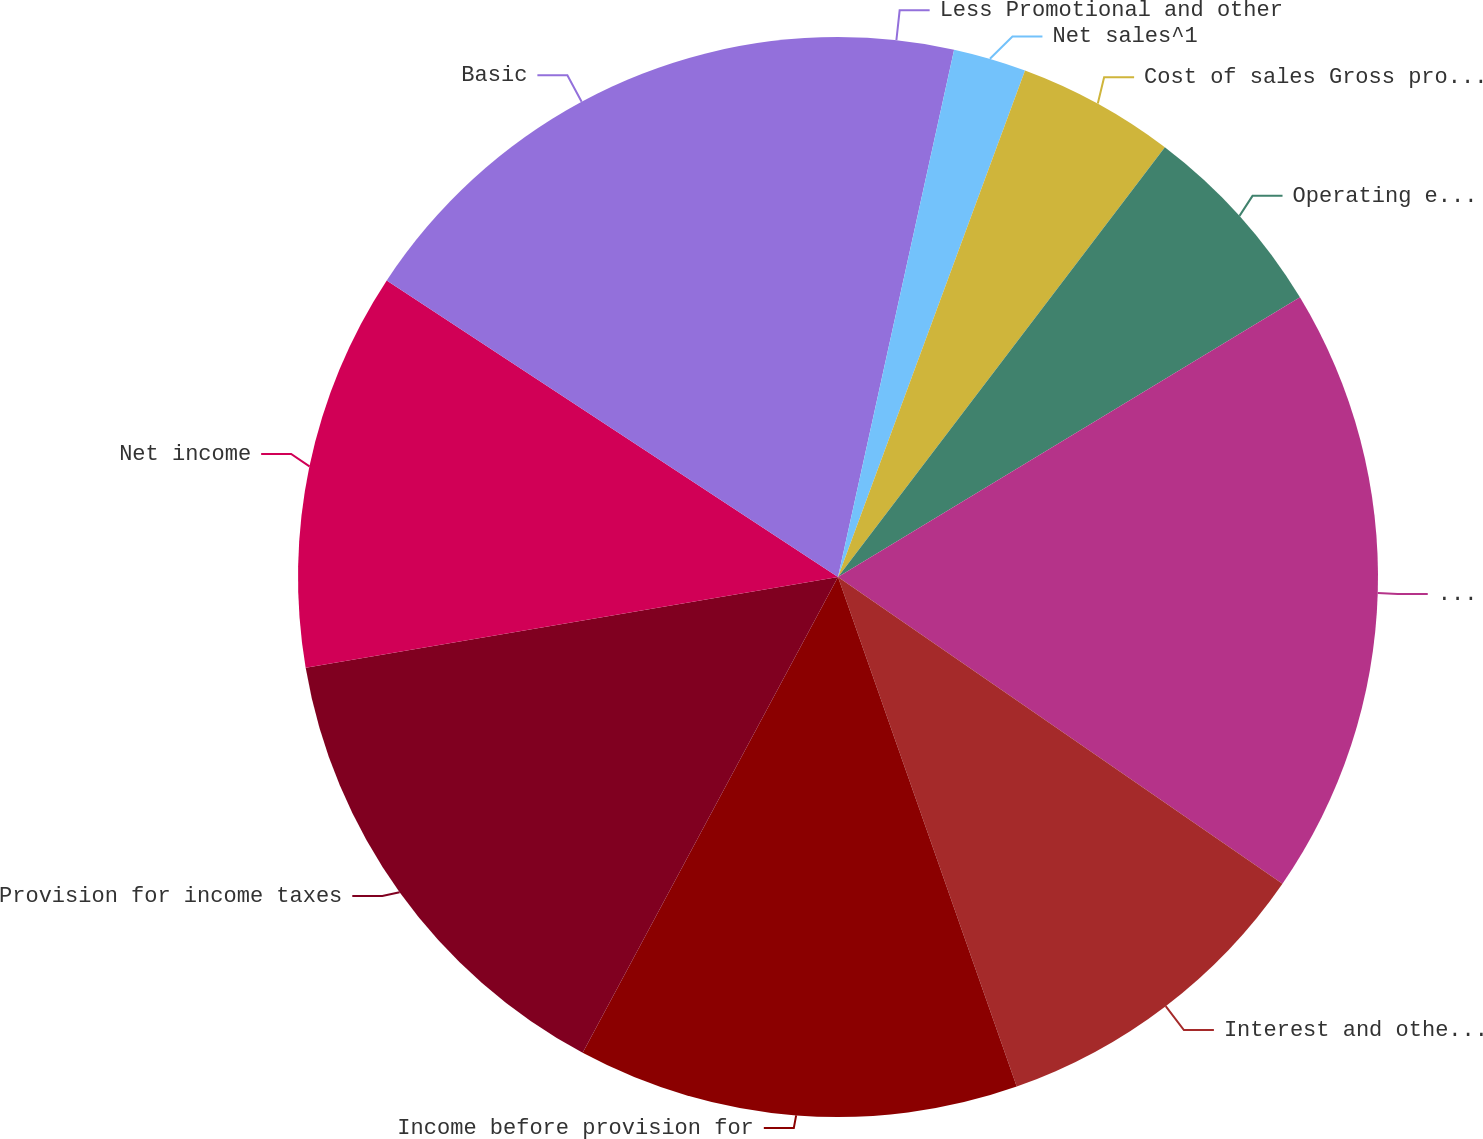Convert chart to OTSL. <chart><loc_0><loc_0><loc_500><loc_500><pie_chart><fcel>Less Promotional and other<fcel>Net sales^1<fcel>Cost of sales Gross profit^1<fcel>Operating expenses ^2<fcel>Operating income ^12<fcel>Interest and other income net<fcel>Income before provision for<fcel>Provision for income taxes<fcel>Net income<fcel>Basic<nl><fcel>3.45%<fcel>2.18%<fcel>4.72%<fcel>5.99%<fcel>18.28%<fcel>10.02%<fcel>13.21%<fcel>14.48%<fcel>11.94%<fcel>15.75%<nl></chart> 